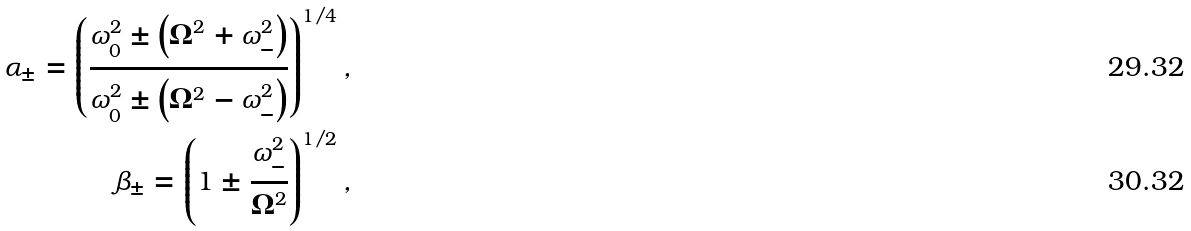<formula> <loc_0><loc_0><loc_500><loc_500>\alpha _ { \pm } = \left ( \frac { \omega _ { 0 } ^ { 2 } \pm \left ( \Omega ^ { 2 } + \omega _ { - } ^ { 2 } \right ) } { \omega _ { 0 } ^ { 2 } \pm \left ( \Omega ^ { 2 } - \omega _ { - } ^ { 2 } \right ) } \right ) ^ { 1 / 4 } , \\ \beta _ { \pm } = \left ( 1 \pm \frac { \omega _ { - } ^ { 2 } } { \Omega ^ { 2 } } \right ) ^ { 1 / 2 } ,</formula> 